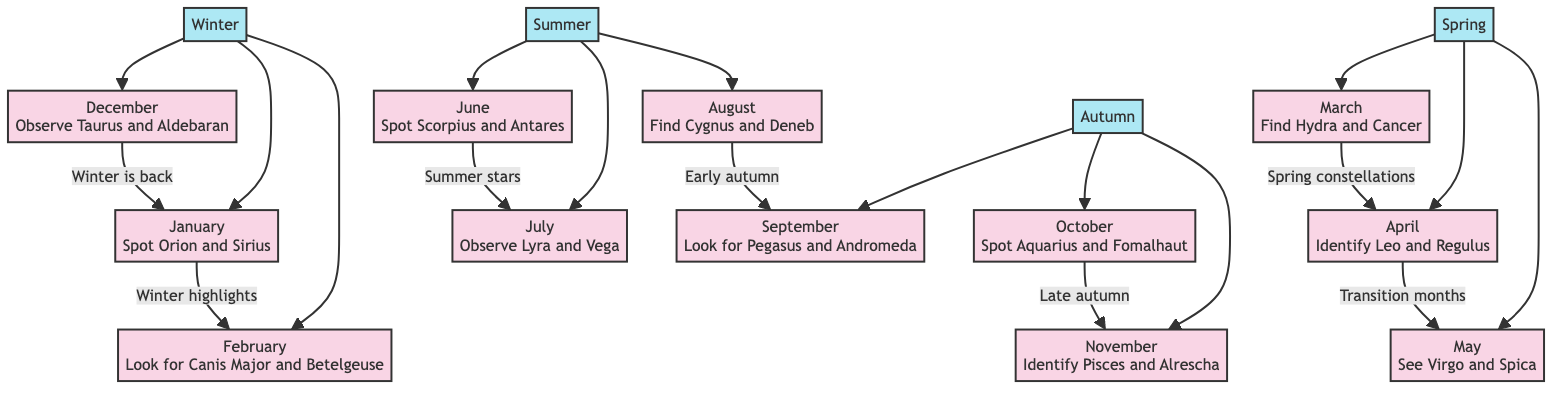What constellations are visible in January? January's node in the diagram highlights both Orion and Sirius as the prominent constellations visible during that month.
Answer: Orion and Sirius What is the transition month from spring to summer? According to the diagram, the flow from May leads to June, indicating that May is the last month of spring before the transition into summer.
Answer: May Which month showcases the constellation Pegasus? The diagram indicates that Pegasus is visible in September, as shown in the September node.
Answer: September How many distinct months are listed in the diagram? The diagram contains twelve distinct months, each corresponding to a node.
Answer: Twelve Which constellation is associated with the summer month of July? The July node in the diagram shows that Lyra and Vega are the constellations prominent during that month.
Answer: Lyra and Vega What is the first constellation to be identified in the year? Based on the diagram, Orion is the first constellation identified in January, making it the earliest constellation of the year.
Answer: Orion Which season connects April and May? The diagram shows that April leads directly into May, and since both are in the same grouping, it's clear that they belong to the spring season.
Answer: Spring Which constellation can be observed in December? The December node indicates that Taurus and Aldebaran are the constellations visible during that month.
Answer: Taurus and Aldebaran What is the relationship between the months of August and September? According to the diagram, August leads to September, showing a sequential relationship that indicates the order of months and the seasonal transition into autumn.
Answer: Sequential relationship 